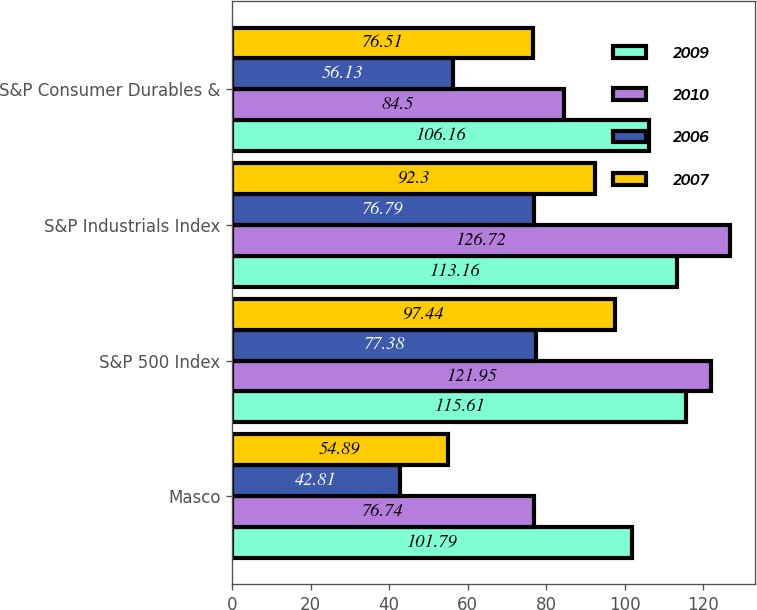Convert chart. <chart><loc_0><loc_0><loc_500><loc_500><stacked_bar_chart><ecel><fcel>Masco<fcel>S&P 500 Index<fcel>S&P Industrials Index<fcel>S&P Consumer Durables &<nl><fcel>2009<fcel>101.79<fcel>115.61<fcel>113.16<fcel>106.16<nl><fcel>2010<fcel>76.74<fcel>121.95<fcel>126.72<fcel>84.5<nl><fcel>2006<fcel>42.81<fcel>77.38<fcel>76.79<fcel>56.13<nl><fcel>2007<fcel>54.89<fcel>97.44<fcel>92.3<fcel>76.51<nl></chart> 